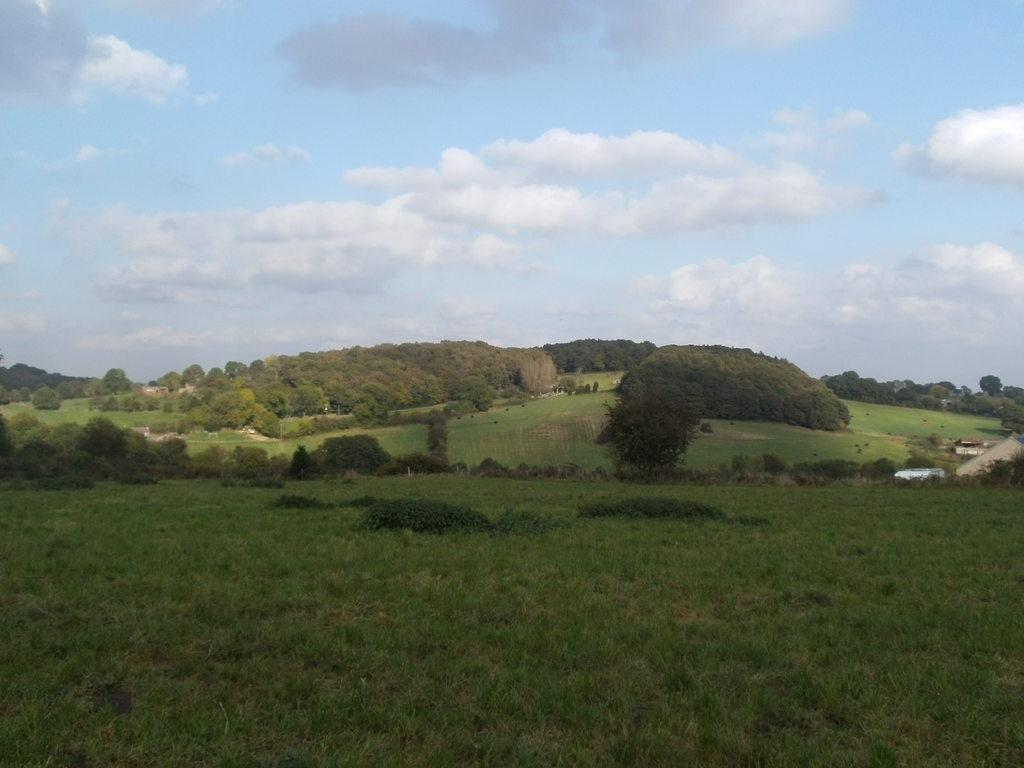What type of vegetation can be seen in the image? There are trees, grass, and plants in the image. What is visible in the background of the image? The sky is visible in the image. What can be seen in the sky? Clouds are present in the sky. What type of polish is being applied to the snakes in the image? There are no snakes or polish present in the image. How does the throat of the person in the image look? There is no person present in the image, so it is not possible to determine the appearance of their throat. 